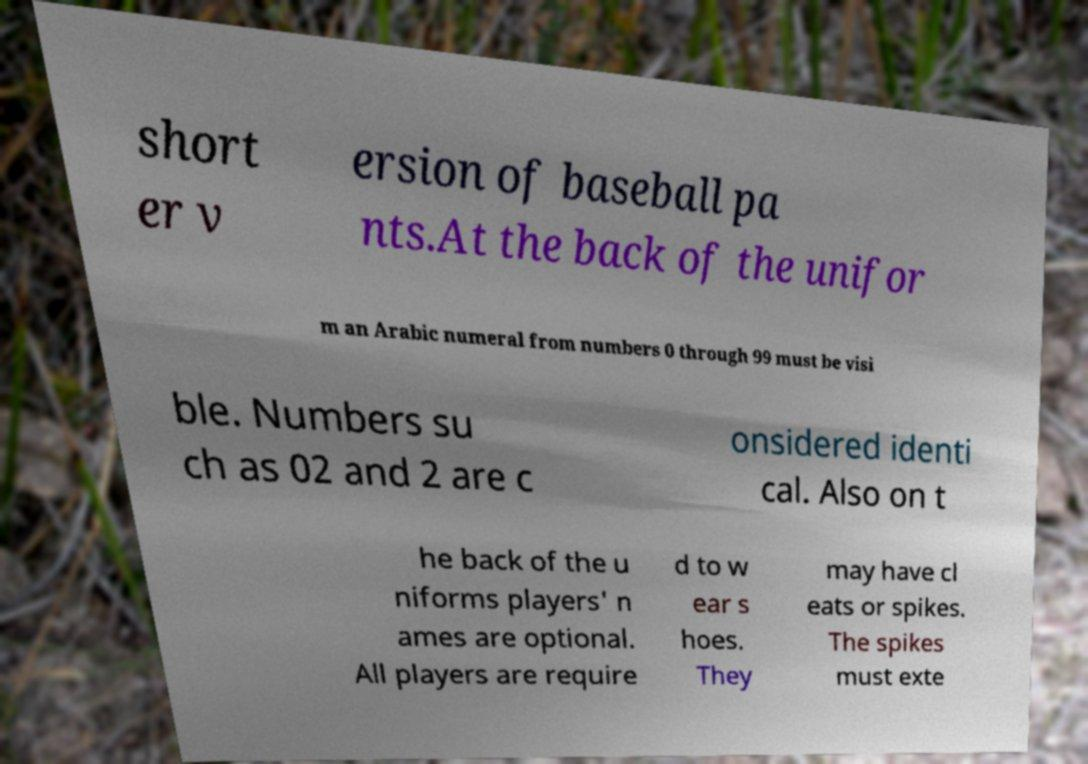I need the written content from this picture converted into text. Can you do that? short er v ersion of baseball pa nts.At the back of the unifor m an Arabic numeral from numbers 0 through 99 must be visi ble. Numbers su ch as 02 and 2 are c onsidered identi cal. Also on t he back of the u niforms players' n ames are optional. All players are require d to w ear s hoes. They may have cl eats or spikes. The spikes must exte 